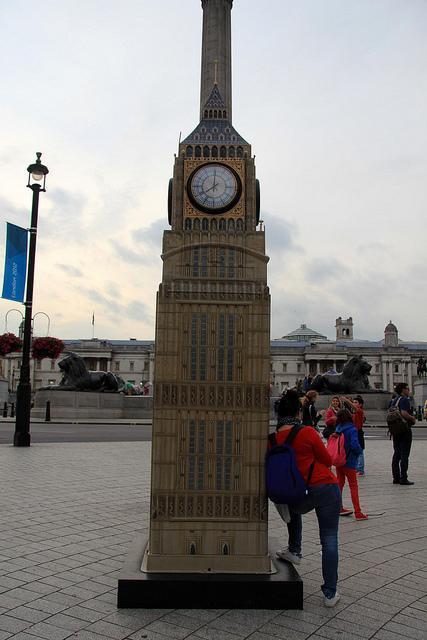How many red shirts are there?
Give a very brief answer. 2. How many people are visible?
Give a very brief answer. 3. 